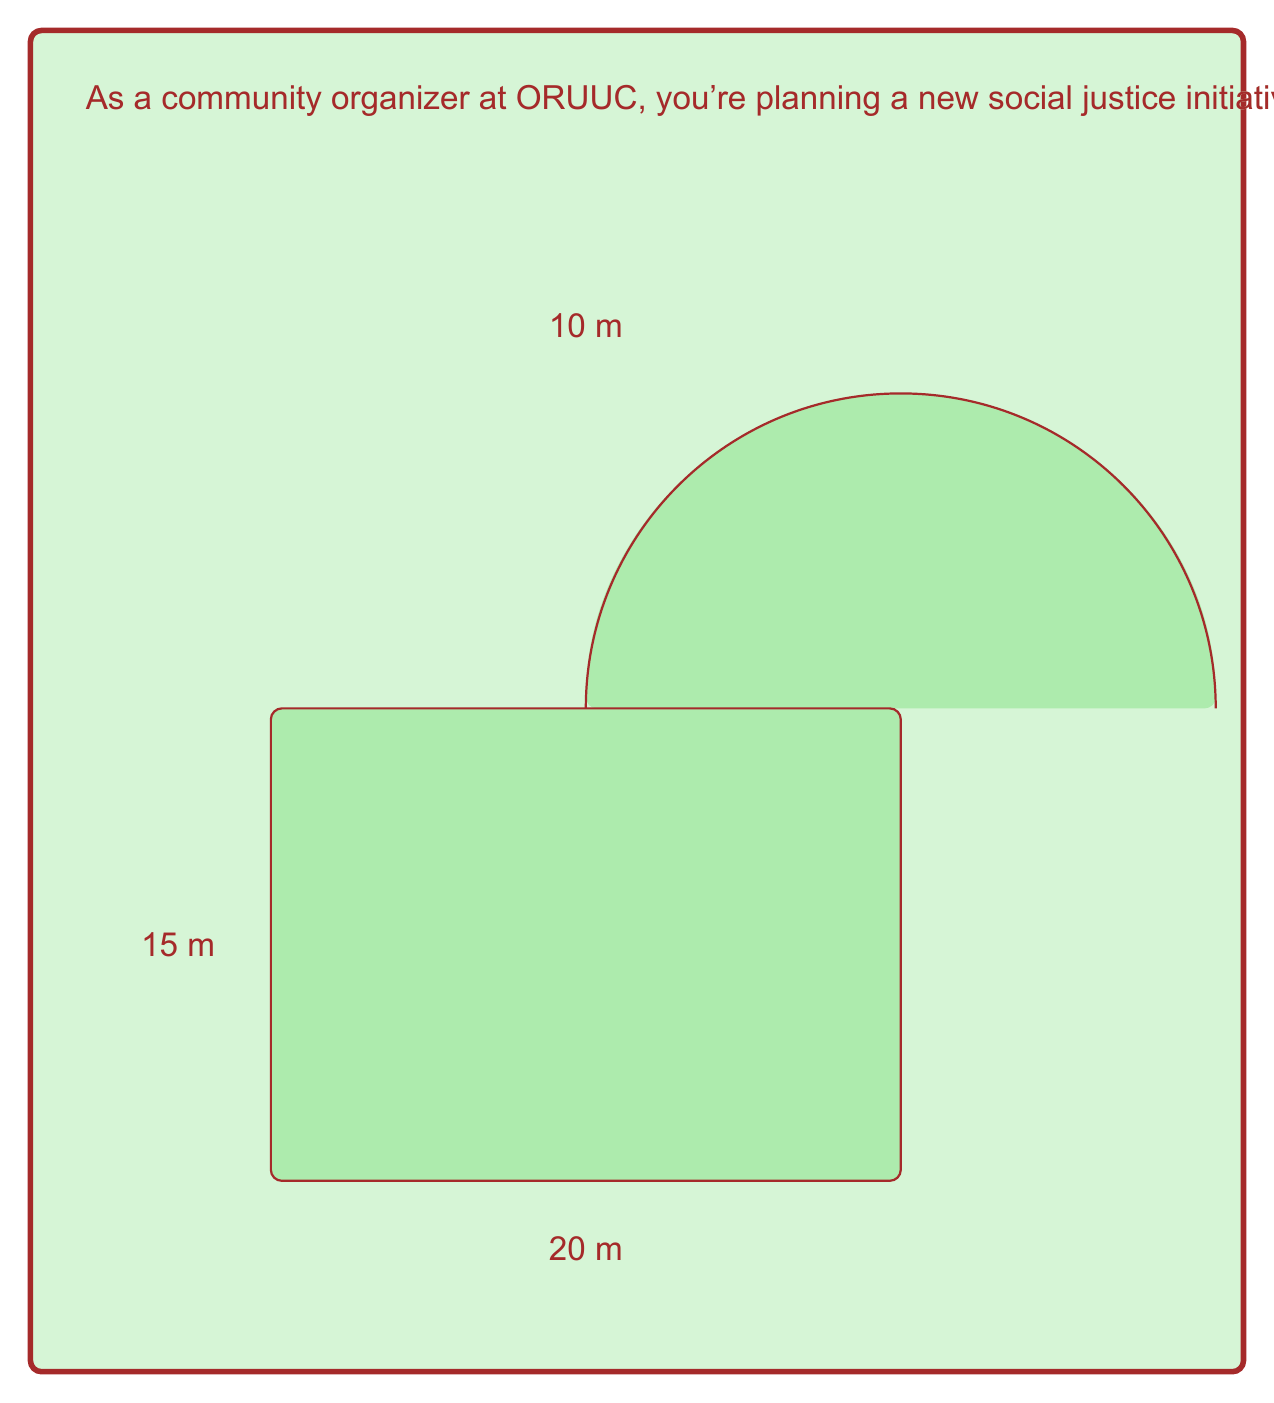Could you help me with this problem? To solve this problem, we need to calculate the areas of the rectangle and the semicircle separately, then add them together.

1. Area of the rectangle:
   $$ A_{rectangle} = length \times width = 20 \text{ m} \times 15 \text{ m} = 300 \text{ m}^2 $$

2. Area of the semicircle:
   The diameter of the semicircle is equal to the width of the rectangle, which is 20 m.
   Therefore, the radius is half of this, 10 m.
   
   The formula for the area of a circle is $A = \pi r^2$, so for a semicircle, we use half of this:
   $$ A_{semicircle} = \frac{1}{2} \pi r^2 = \frac{1}{2} \pi (10 \text{ m})^2 = 50\pi \text{ m}^2 $$

3. Total area:
   $$ A_{total} = A_{rectangle} + A_{semicircle} = 300 \text{ m}^2 + 50\pi \text{ m}^2 $$

4. Simplifying:
   $$ A_{total} = (300 + 50\pi) \text{ m}^2 \approx 457.08 \text{ m}^2 $$
Answer: The total area of the community garden is $(300 + 50\pi) \text{ m}^2$ or approximately $457.08 \text{ m}^2$. 